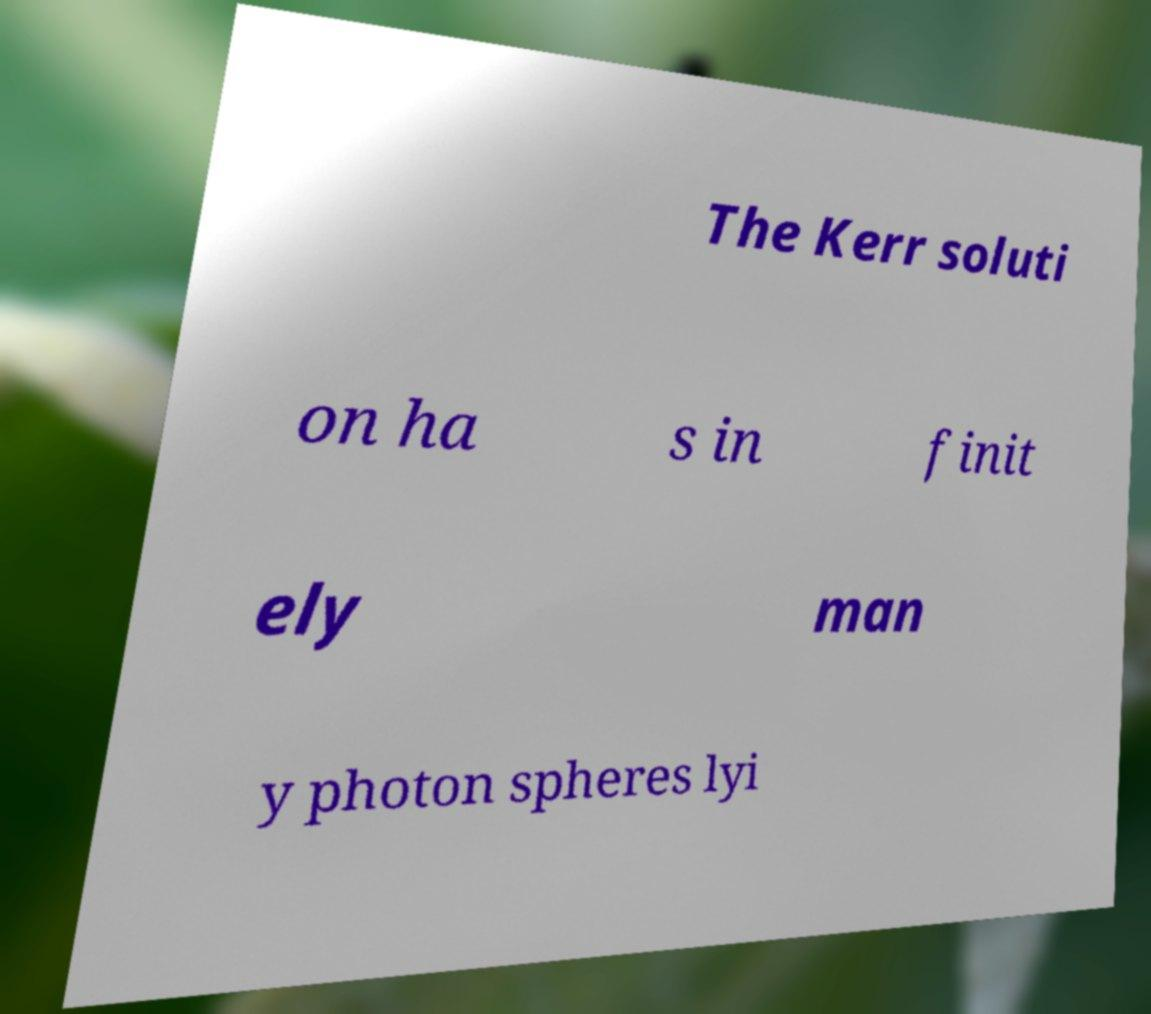Could you assist in decoding the text presented in this image and type it out clearly? The Kerr soluti on ha s in finit ely man y photon spheres lyi 